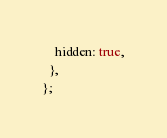<code> <loc_0><loc_0><loc_500><loc_500><_TypeScript_>    hidden: true,
  },
};
</code> 